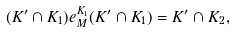Convert formula to latex. <formula><loc_0><loc_0><loc_500><loc_500>( K ^ { \prime } \cap K _ { 1 } ) e ^ { K _ { 1 } } _ { M } ( K ^ { \prime } \cap K _ { 1 } ) = K ^ { \prime } \cap K _ { 2 } ,</formula> 